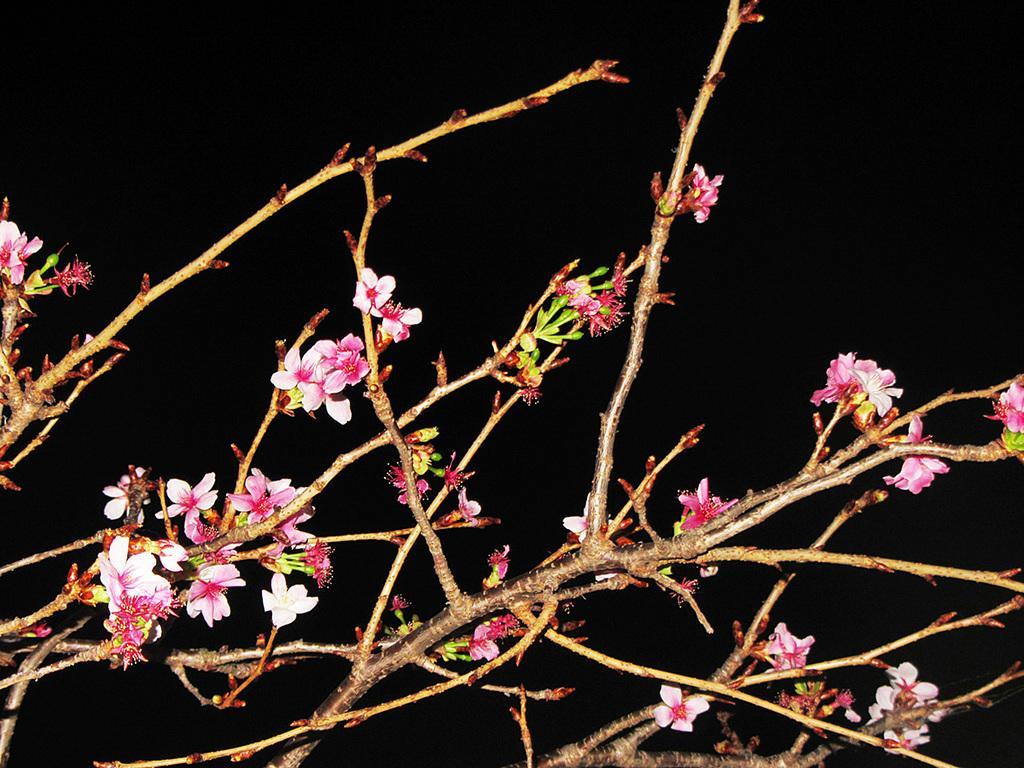What can be seen on the tree branches in the image? There are flowers on the tree branches in the image. What is the color of the background in the image? The background of the image is dark. What type of page is being turned in the image? There is no page or indication of turning pages in the image; it features tree branches with flowers and a dark background. 